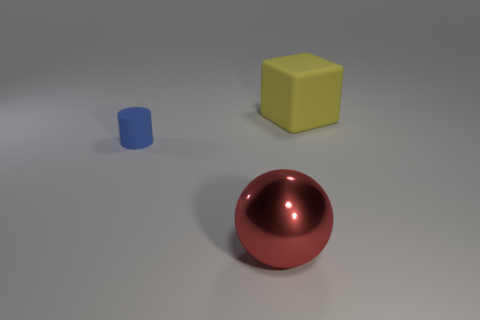Is the number of big yellow rubber objects behind the cylinder the same as the number of small blue matte things that are in front of the red metal object?
Your answer should be compact. No. What color is the large metal ball?
Give a very brief answer. Red. What number of objects are rubber things on the left side of the large block or big yellow cubes?
Offer a very short reply. 2. There is a thing that is on the left side of the big red sphere; does it have the same size as the thing that is in front of the small cylinder?
Ensure brevity in your answer.  No. Is there anything else that has the same material as the red thing?
Offer a very short reply. No. How many things are either objects in front of the cylinder or objects that are behind the large red metallic object?
Offer a very short reply. 3. Is the material of the blue thing the same as the object behind the cylinder?
Your answer should be very brief. Yes. What is the shape of the thing that is on the right side of the blue rubber cylinder and behind the big red metallic object?
Make the answer very short. Cube. What shape is the tiny blue object?
Keep it short and to the point. Cylinder. The rubber object in front of the big object that is behind the red sphere is what color?
Your answer should be very brief. Blue. 